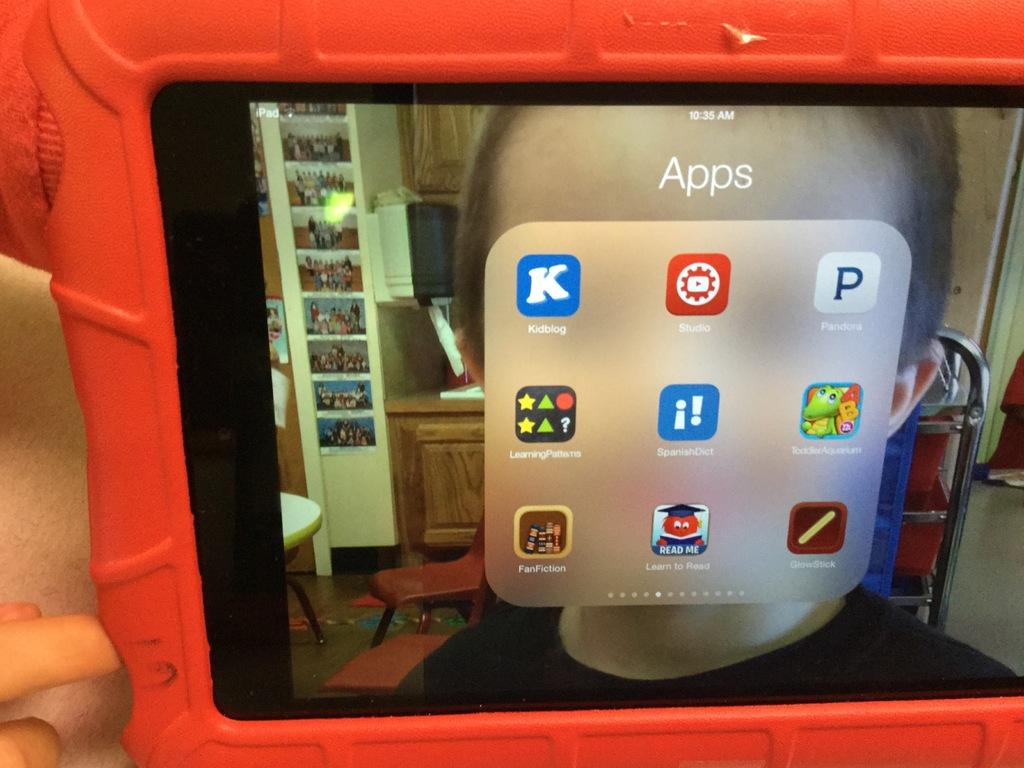What is the app with the k logo called?
Provide a short and direct response. Kidblog. 